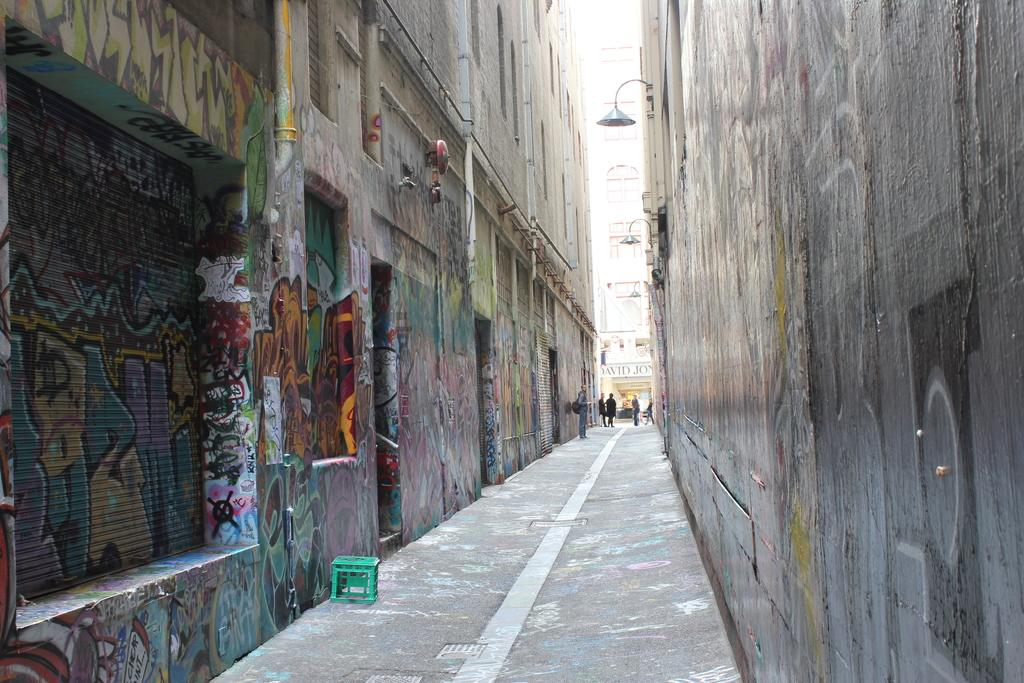What type of setting is depicted in the image? The image shows an alley view. What objects can be seen in the alley? There are chairpersons and a lamp visible in the image. What type of structures are present in the background? There are buildings in the image. Where are the chickens located in the image? There are no chickens present in the image. What type of tool is being used to clean the alley in the image? There is no tool or activity related to cleaning visible in the image. 